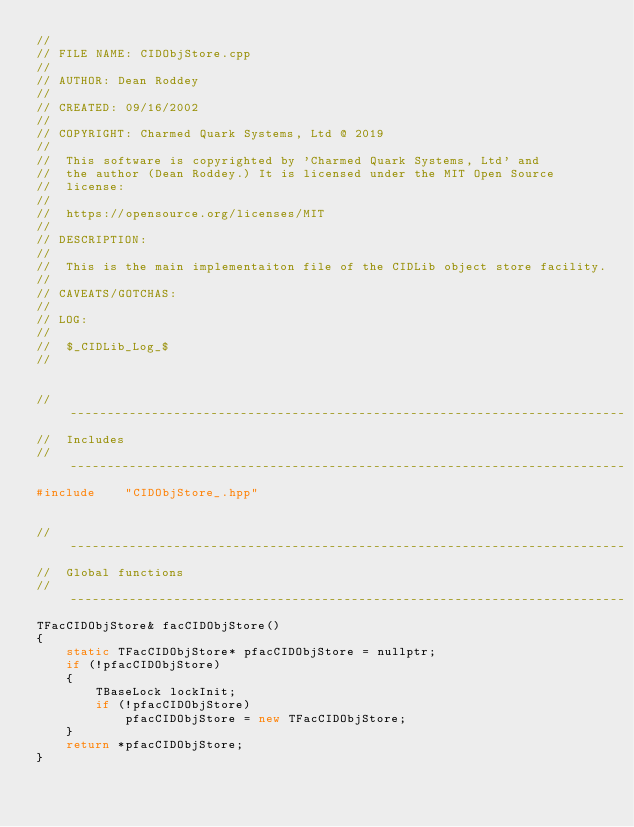Convert code to text. <code><loc_0><loc_0><loc_500><loc_500><_C++_>//
// FILE NAME: CIDObjStore.cpp
//
// AUTHOR: Dean Roddey
//
// CREATED: 09/16/2002
//
// COPYRIGHT: Charmed Quark Systems, Ltd @ 2019
//
//  This software is copyrighted by 'Charmed Quark Systems, Ltd' and
//  the author (Dean Roddey.) It is licensed under the MIT Open Source
//  license:
//
//  https://opensource.org/licenses/MIT
//
// DESCRIPTION:
//
//  This is the main implementaiton file of the CIDLib object store facility.
//
// CAVEATS/GOTCHAS:
//
// LOG:
//
//  $_CIDLib_Log_$
//


// ---------------------------------------------------------------------------
//  Includes
// ---------------------------------------------------------------------------
#include    "CIDObjStore_.hpp"


// ---------------------------------------------------------------------------
//  Global functions
// ---------------------------------------------------------------------------
TFacCIDObjStore& facCIDObjStore()
{
    static TFacCIDObjStore* pfacCIDObjStore = nullptr;
    if (!pfacCIDObjStore)
    {
        TBaseLock lockInit;
        if (!pfacCIDObjStore)
            pfacCIDObjStore = new TFacCIDObjStore;
    }
    return *pfacCIDObjStore;
}


</code> 